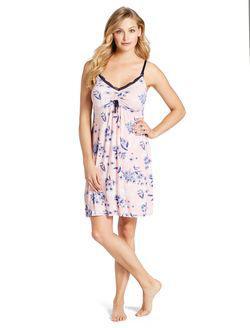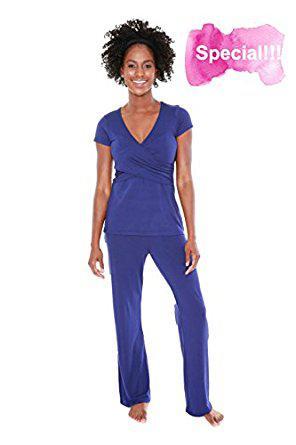The first image is the image on the left, the second image is the image on the right. For the images displayed, is the sentence "In at least 1 of the images, 1 person is wearing patterned white pants." factually correct? Answer yes or no. No. The first image is the image on the left, the second image is the image on the right. Given the left and right images, does the statement "One women's pajama outfit has a matching short robe." hold true? Answer yes or no. No. 